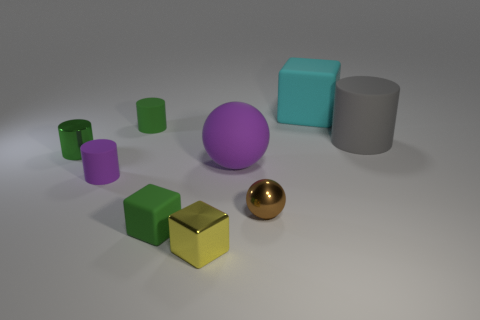Add 1 cylinders. How many objects exist? 10 Subtract all metallic cylinders. How many cylinders are left? 3 Subtract 1 spheres. How many spheres are left? 1 Subtract all cyan cubes. How many cubes are left? 2 Subtract all balls. How many objects are left? 7 Subtract all purple blocks. Subtract all red balls. How many blocks are left? 3 Subtract all purple spheres. How many green cubes are left? 1 Subtract all large gray rubber cylinders. Subtract all small green rubber cylinders. How many objects are left? 7 Add 3 small rubber blocks. How many small rubber blocks are left? 4 Add 9 tiny cyan blocks. How many tiny cyan blocks exist? 9 